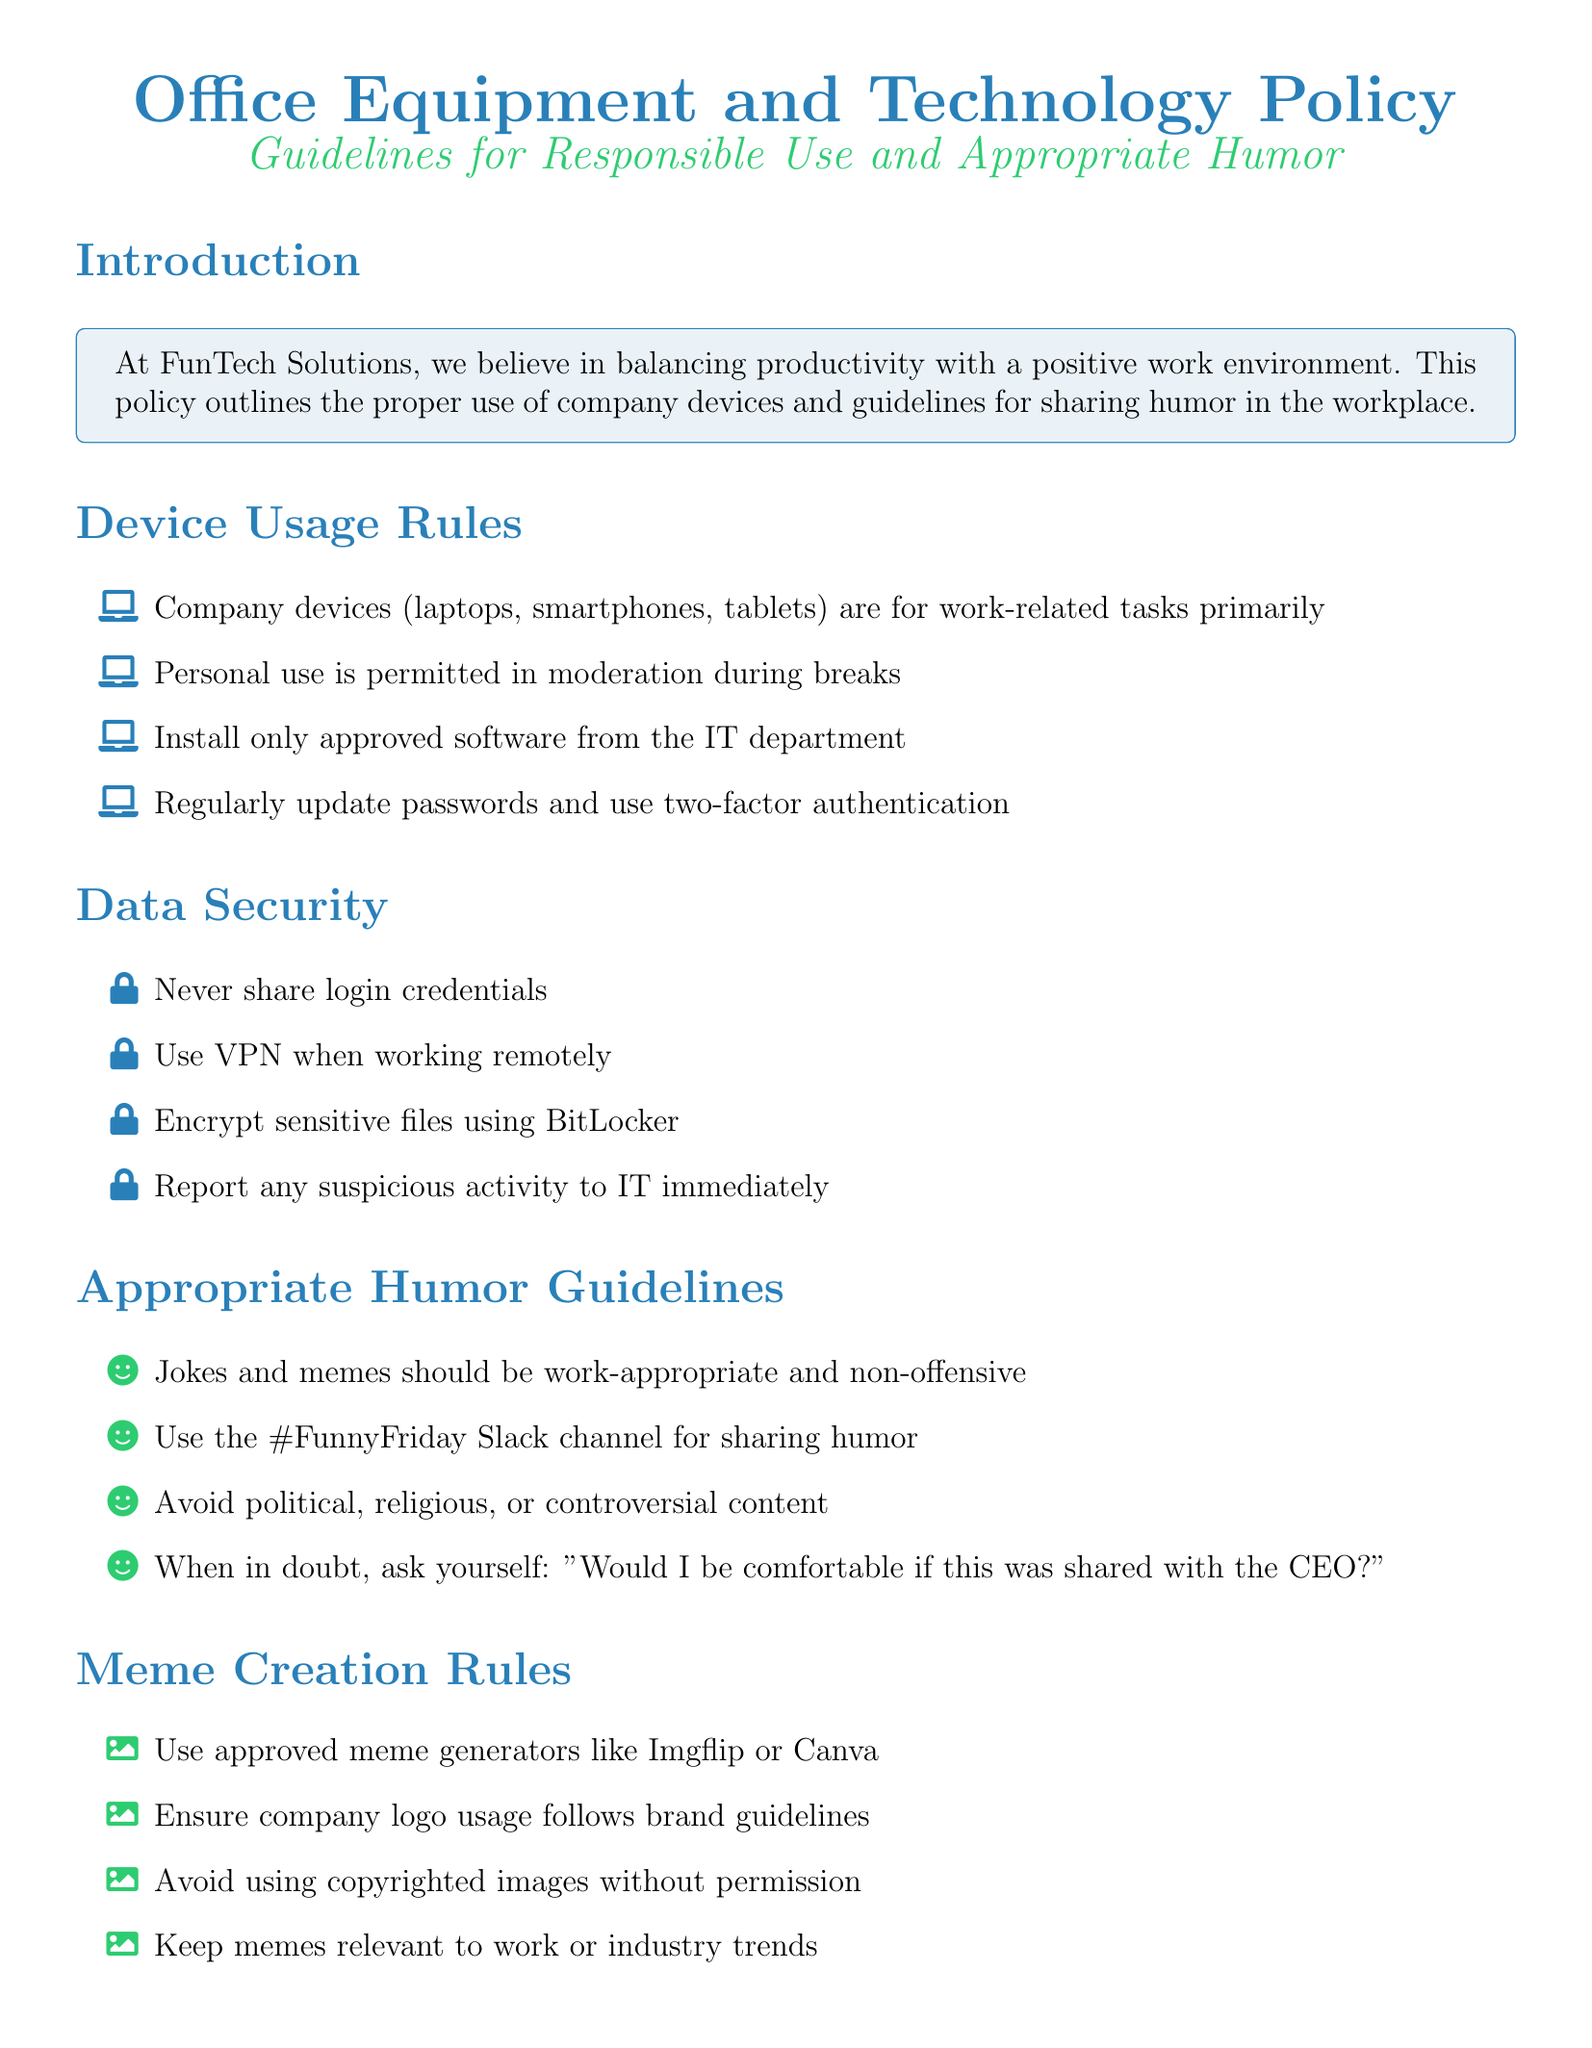What is the primary purpose of company devices? The primary purpose of company devices is to facilitate work-related tasks.
Answer: work-related tasks What channel should humor be shared on? The document specifies using the #FunnyFriday Slack channel for sharing humor.
Answer: #FunnyFriday What should you do when in doubt about sharing a joke? When in doubt, ask yourself if you'd be comfortable sharing it with the CEO.
Answer: share it with the CEO What is the maximum consequence for serious breaches? Serious breaches may involve legal action, which is the highest consequence stated.
Answer: legal action What types of images should be avoided in memes? The document advises against using copyrighted images without permission.
Answer: copyrighted images 